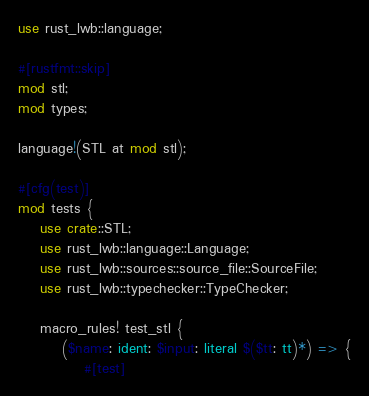<code> <loc_0><loc_0><loc_500><loc_500><_Rust_>use rust_lwb::language;

#[rustfmt::skip]
mod stl;
mod types;

language!(STL at mod stl);

#[cfg(test)]
mod tests {
    use crate::STL;
    use rust_lwb::language::Language;
    use rust_lwb::sources::source_file::SourceFile;
    use rust_lwb::typechecker::TypeChecker;

    macro_rules! test_stl {
        ($name: ident: $input: literal $($tt: tt)*) => {
            #[test]</code> 